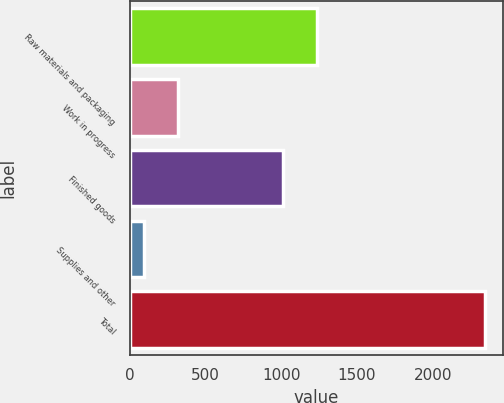Convert chart to OTSL. <chart><loc_0><loc_0><loc_500><loc_500><bar_chart><fcel>Raw materials and packaging<fcel>Work in progress<fcel>Finished goods<fcel>Supplies and other<fcel>Total<nl><fcel>1233.85<fcel>316.75<fcel>1008.1<fcel>91<fcel>2348.5<nl></chart> 